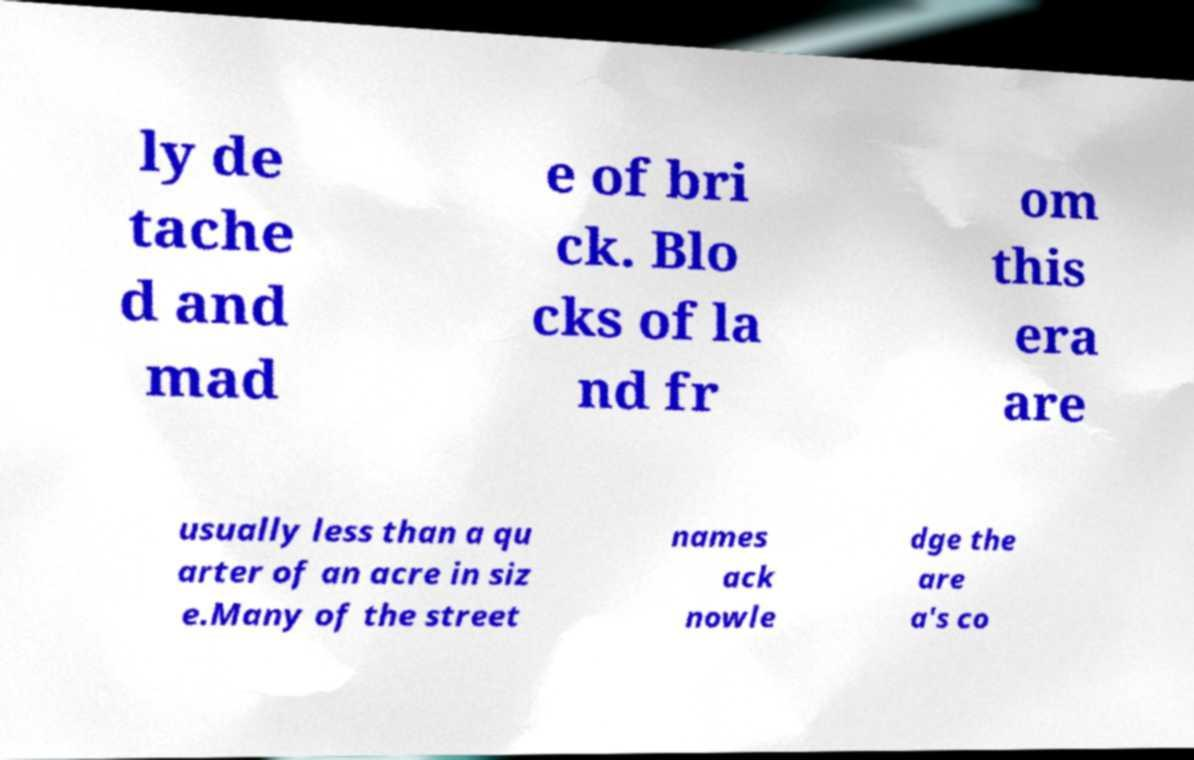Please read and relay the text visible in this image. What does it say? ly de tache d and mad e of bri ck. Blo cks of la nd fr om this era are usually less than a qu arter of an acre in siz e.Many of the street names ack nowle dge the are a's co 